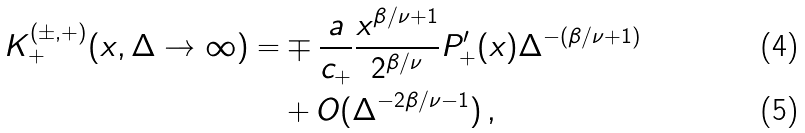<formula> <loc_0><loc_0><loc_500><loc_500>K _ { + } ^ { ( \pm , + ) } ( x , \Delta \rightarrow \infty ) = & \mp \frac { a } { c _ { + } } \frac { x ^ { \beta / \nu + 1 } } { 2 ^ { \beta / \nu } } P _ { + } ^ { \prime } ( x ) \Delta ^ { - ( \beta / \nu + 1 ) } \\ & + O ( \Delta ^ { - 2 \beta / \nu - 1 } ) \, ,</formula> 